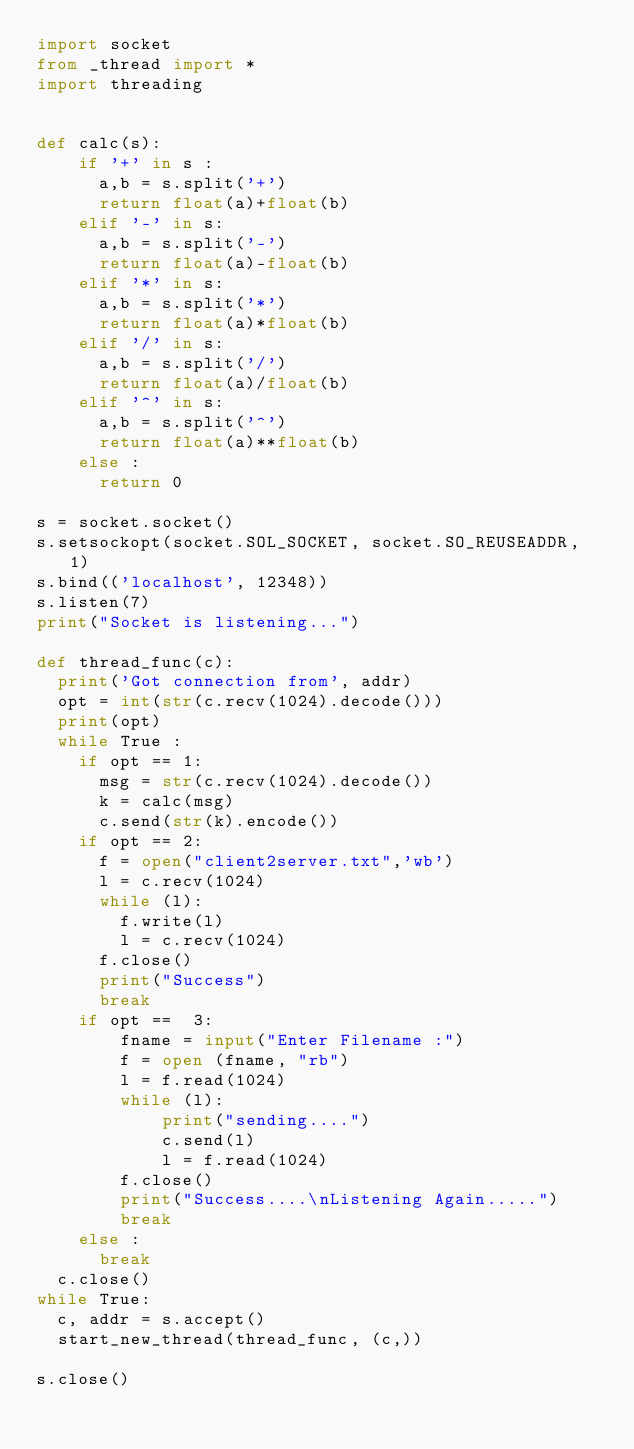Convert code to text. <code><loc_0><loc_0><loc_500><loc_500><_Python_>import socket
from _thread import *
import threading


def calc(s):
		if '+' in s :
			a,b = s.split('+')
			return float(a)+float(b)
		elif '-' in s:
			a,b = s.split('-')
			return float(a)-float(b)
		elif '*' in s:
			a,b = s.split('*')
			return float(a)*float(b)
		elif '/' in s:
			a,b = s.split('/')
			return float(a)/float(b)
		elif '^' in s:
			a,b = s.split('^')
			return float(a)**float(b)
		else :
			return 0

s = socket.socket()
s.setsockopt(socket.SOL_SOCKET, socket.SO_REUSEADDR, 1)
s.bind(('localhost', 12348))
s.listen(7) 
print("Socket is listening...")

def thread_func(c):
	print('Got connection from', addr)
	opt = int(str(c.recv(1024).decode()))
	print(opt)
	while True :
		if opt == 1:
			msg = str(c.recv(1024).decode())
			k = calc(msg)
			c.send(str(k).encode())
		if opt == 2:
			f = open("client2server.txt",'wb')
			l = c.recv(1024)
			while (l):
				f.write(l)
				l = c.recv(1024)
			f.close()
			print("Success")
			break
		if opt ==  3:
		    fname = input("Enter Filename :")
		    f = open (fname, "rb")
		    l = f.read(1024)
		    while (l):
		        print("sending....")
		        c.send(l)
		        l = f.read(1024)
		    f.close()
		    print("Success....\nListening Again.....")
		    break
		else :
			break
	c.close() 
while True: 
	c, addr = s.accept()  
	start_new_thread(thread_func, (c,))     
	
s.close()
</code> 